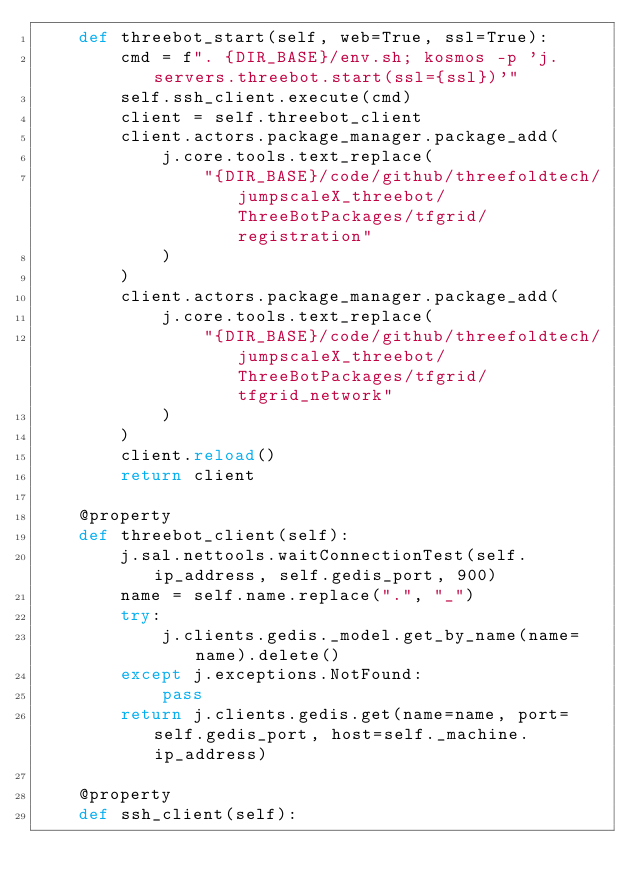Convert code to text. <code><loc_0><loc_0><loc_500><loc_500><_Python_>    def threebot_start(self, web=True, ssl=True):
        cmd = f". {DIR_BASE}/env.sh; kosmos -p 'j.servers.threebot.start(ssl={ssl})'"
        self.ssh_client.execute(cmd)
        client = self.threebot_client
        client.actors.package_manager.package_add(
            j.core.tools.text_replace(
                "{DIR_BASE}/code/github/threefoldtech/jumpscaleX_threebot/ThreeBotPackages/tfgrid/registration"
            )
        )
        client.actors.package_manager.package_add(
            j.core.tools.text_replace(
                "{DIR_BASE}/code/github/threefoldtech/jumpscaleX_threebot/ThreeBotPackages/tfgrid/tfgrid_network"
            )
        )
        client.reload()
        return client

    @property
    def threebot_client(self):
        j.sal.nettools.waitConnectionTest(self.ip_address, self.gedis_port, 900)
        name = self.name.replace(".", "_")
        try:
            j.clients.gedis._model.get_by_name(name=name).delete()
        except j.exceptions.NotFound:
            pass
        return j.clients.gedis.get(name=name, port=self.gedis_port, host=self._machine.ip_address)

    @property
    def ssh_client(self):</code> 